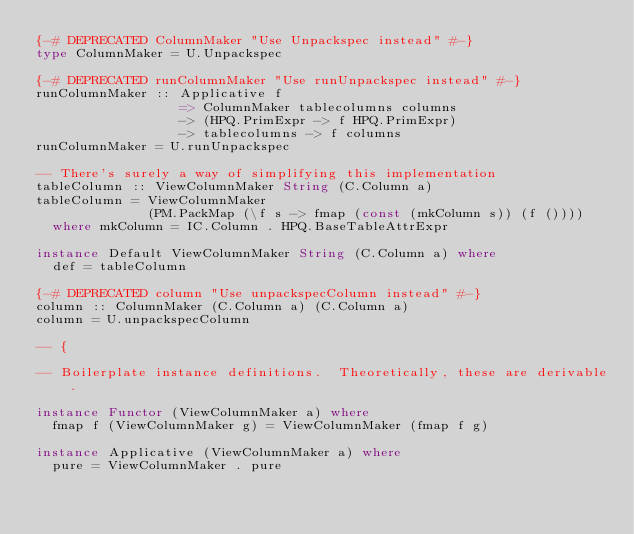Convert code to text. <code><loc_0><loc_0><loc_500><loc_500><_Haskell_>{-# DEPRECATED ColumnMaker "Use Unpackspec instead" #-}
type ColumnMaker = U.Unpackspec

{-# DEPRECATED runColumnMaker "Use runUnpackspec instead" #-}
runColumnMaker :: Applicative f
                  => ColumnMaker tablecolumns columns
                  -> (HPQ.PrimExpr -> f HPQ.PrimExpr)
                  -> tablecolumns -> f columns
runColumnMaker = U.runUnpackspec

-- There's surely a way of simplifying this implementation
tableColumn :: ViewColumnMaker String (C.Column a)
tableColumn = ViewColumnMaker
              (PM.PackMap (\f s -> fmap (const (mkColumn s)) (f ())))
  where mkColumn = IC.Column . HPQ.BaseTableAttrExpr

instance Default ViewColumnMaker String (C.Column a) where
  def = tableColumn

{-# DEPRECATED column "Use unpackspecColumn instead" #-}
column :: ColumnMaker (C.Column a) (C.Column a)
column = U.unpackspecColumn

-- {

-- Boilerplate instance definitions.  Theoretically, these are derivable.

instance Functor (ViewColumnMaker a) where
  fmap f (ViewColumnMaker g) = ViewColumnMaker (fmap f g)

instance Applicative (ViewColumnMaker a) where
  pure = ViewColumnMaker . pure</code> 